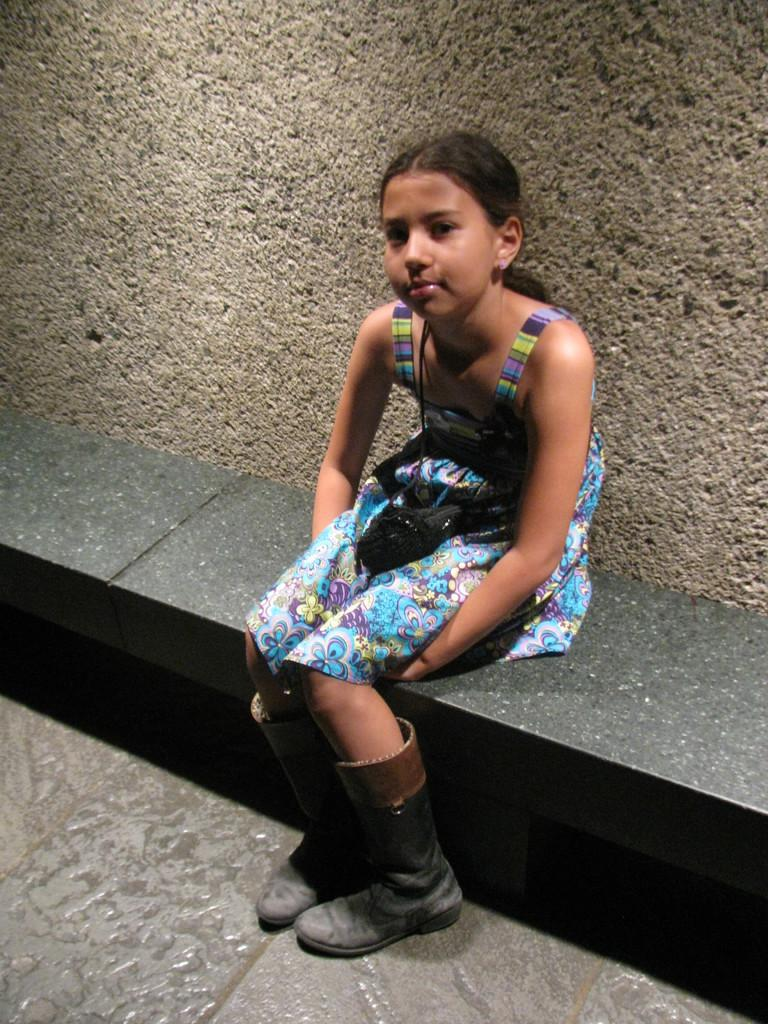What is the main subject of the image? The main subject of the image is a kid. What is the kid wearing in the image? The kid is wearing a multi-color dress and black boots. What is the kid doing in the image? The kid is sitting on a surface. What can be seen in the background of the image? There is a wall in the background of the image. What type of prose is the kid reading in the image? There is no book or any form of reading material present in the image, so it cannot be determined if the kid is reading any prose. 